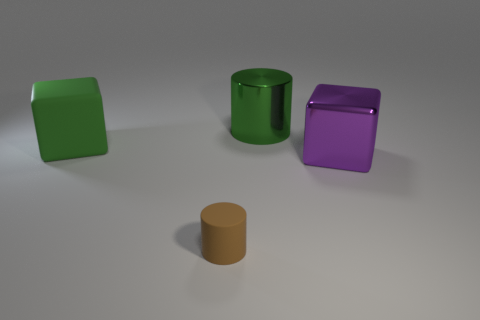Can you tell me the positions of the objects? Sure, from the perspective of the image, there's a green cube on the left, followed by a larger green cylinder in the center. To the right of the cylinder is a purple cube and in front, a smaller tan cylinder. What can you infer about the lighting in this scene? The lighting appears to be coming from above and creates soft shadows on the ground beneath each object, suggesting an indoor setting with a diffuse light source. 